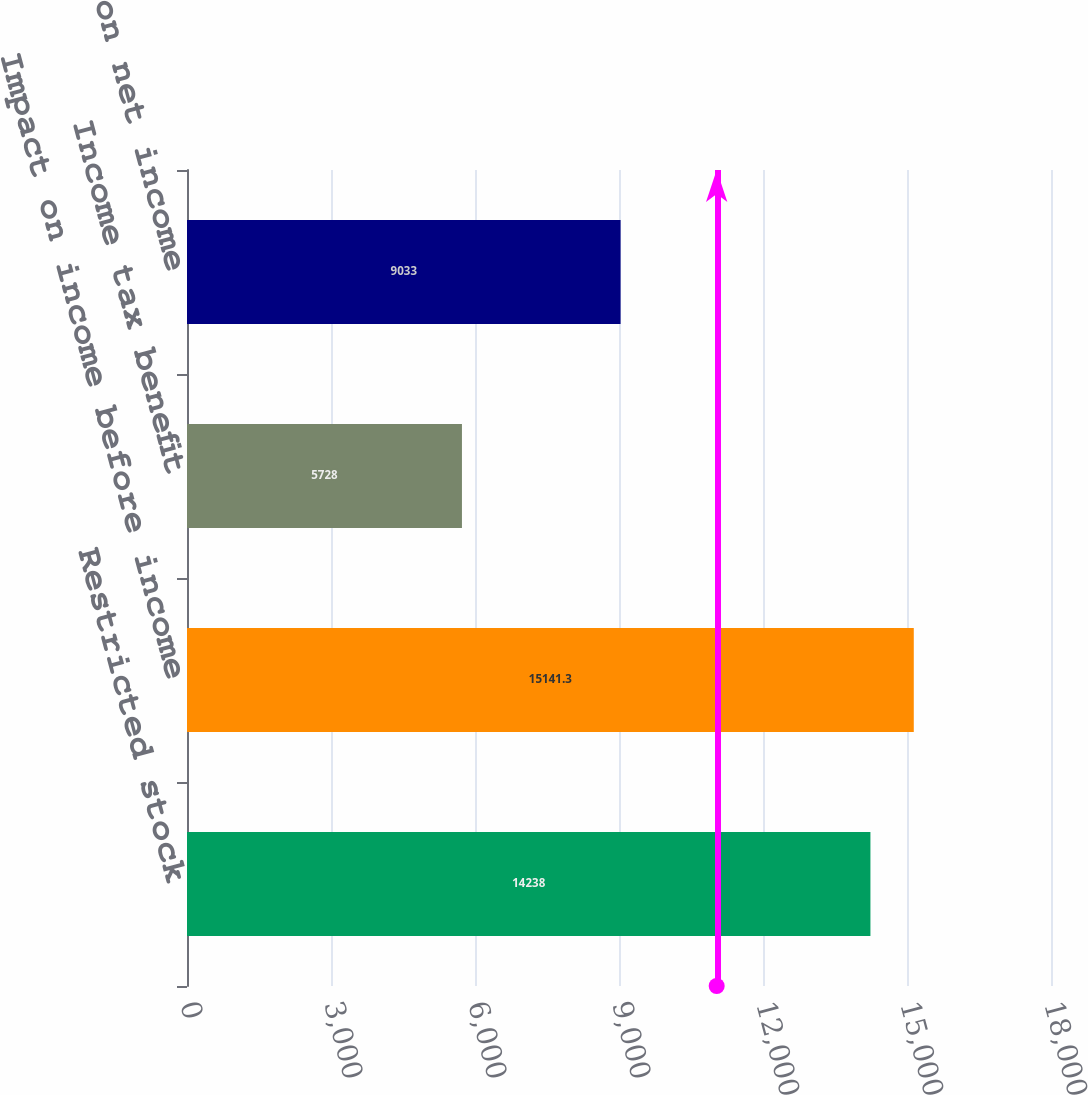<chart> <loc_0><loc_0><loc_500><loc_500><bar_chart><fcel>Restricted stock<fcel>Impact on income before income<fcel>Income tax benefit<fcel>Impact on net income<nl><fcel>14238<fcel>15141.3<fcel>5728<fcel>9033<nl></chart> 